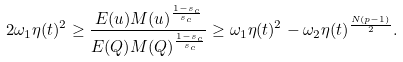Convert formula to latex. <formula><loc_0><loc_0><loc_500><loc_500>2 \omega _ { 1 } \eta ( t ) ^ { 2 } \geq \frac { E ( u ) M ( u ) ^ { \frac { 1 - s _ { c } } { s _ { c } } } } { E ( Q ) M ( Q ) ^ { \frac { 1 - s _ { c } } { s _ { c } } } } \geq \omega _ { 1 } \eta ( t ) ^ { 2 } - \omega _ { 2 } \eta ( t ) ^ { \frac { N ( p - 1 ) } { 2 } } .</formula> 